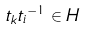Convert formula to latex. <formula><loc_0><loc_0><loc_500><loc_500>t _ { k } { t _ { i } } ^ { - 1 } \in H</formula> 